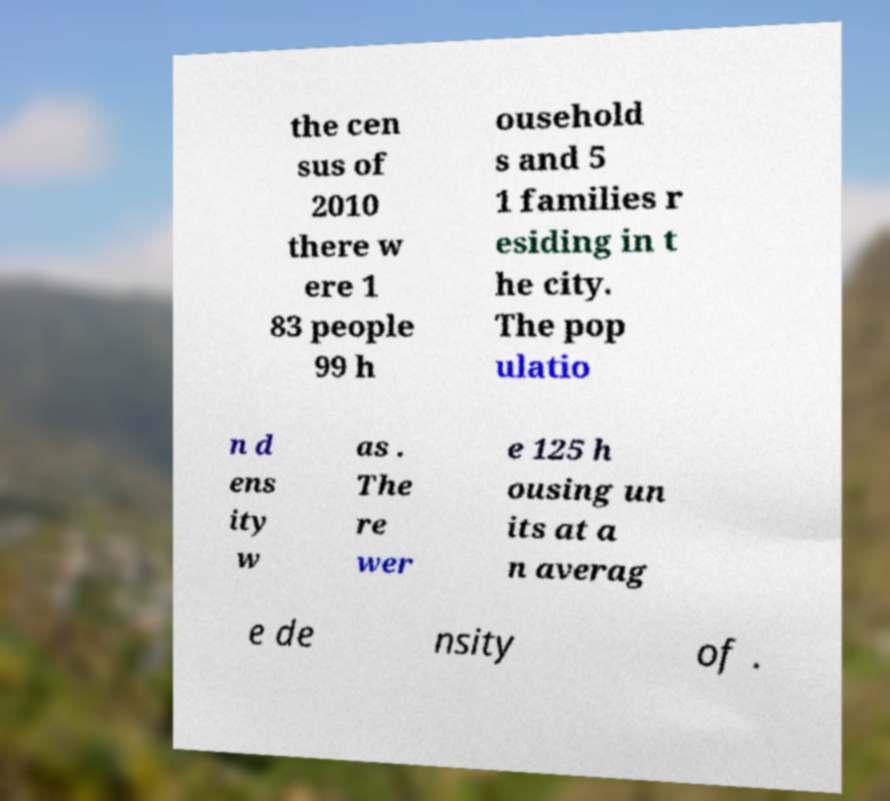Please read and relay the text visible in this image. What does it say? the cen sus of 2010 there w ere 1 83 people 99 h ousehold s and 5 1 families r esiding in t he city. The pop ulatio n d ens ity w as . The re wer e 125 h ousing un its at a n averag e de nsity of . 